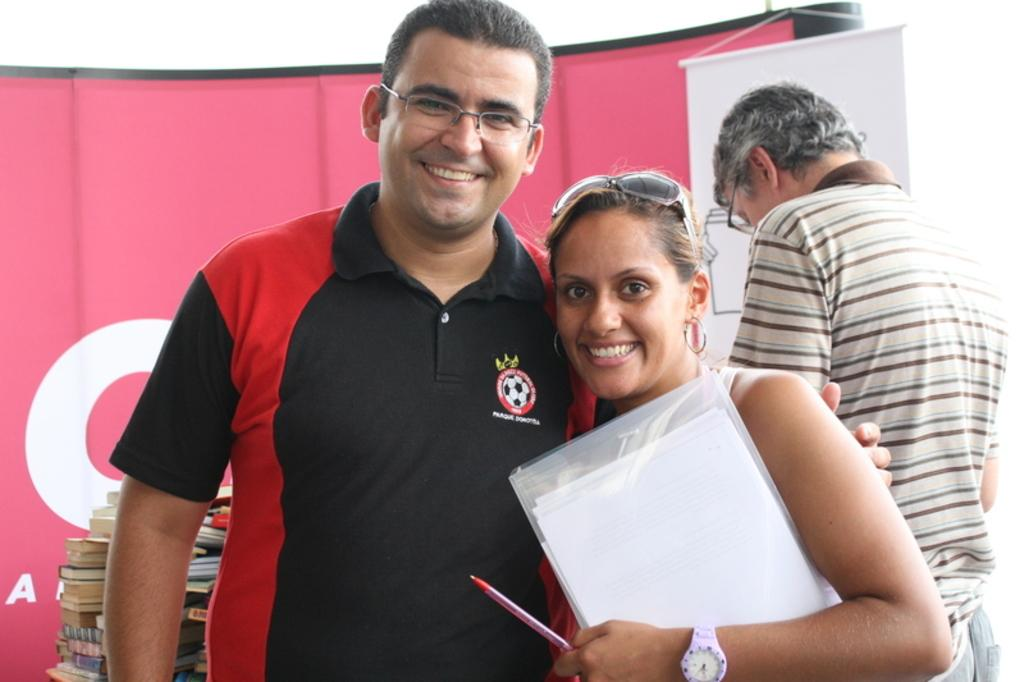How many people are present in the image? There are three people in the image. What are the two people on the left side of the image doing? A man and a woman are watching and smiling. What is the woman holding in her hands? The woman is holding a file and a pen. What can be seen in the background of the image? There are banners and books in the background of the image. What type of corn is being sold in the image? There is no corn present in the image. Can you tell me how many shoes are visible in the image? There is no shoe present in the image. 